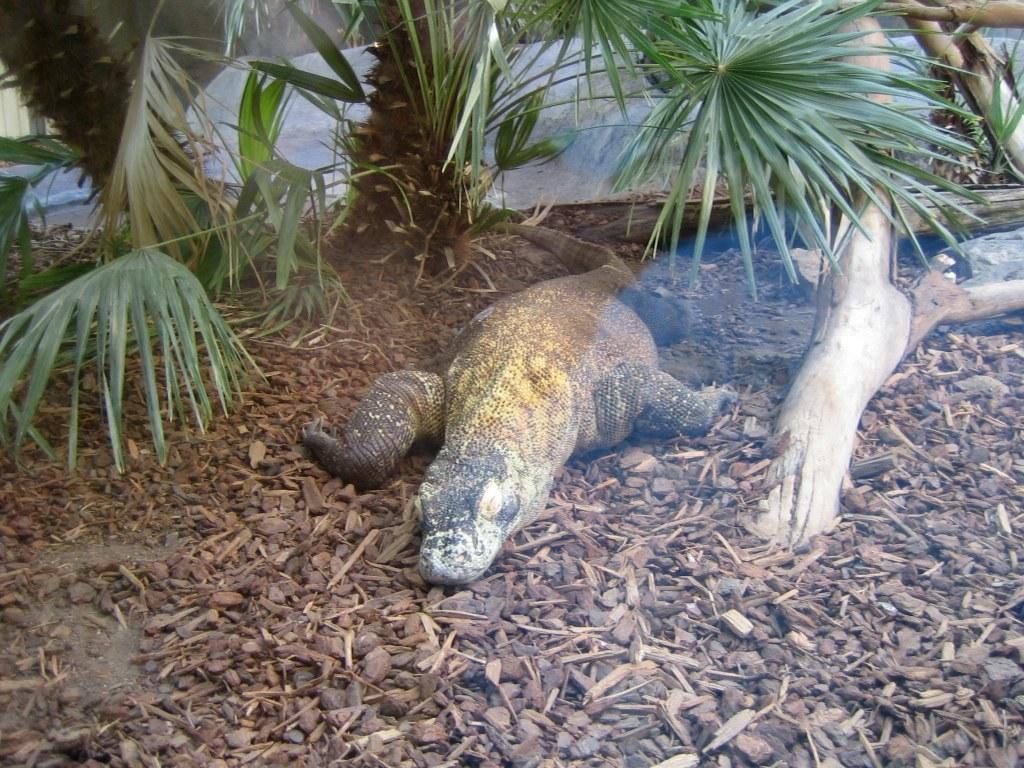In one or two sentences, can you explain what this image depicts? In this picture there is an animal. At the back there are trees. At the bottom there are stones and wooden pieces and there is a tree branch. 